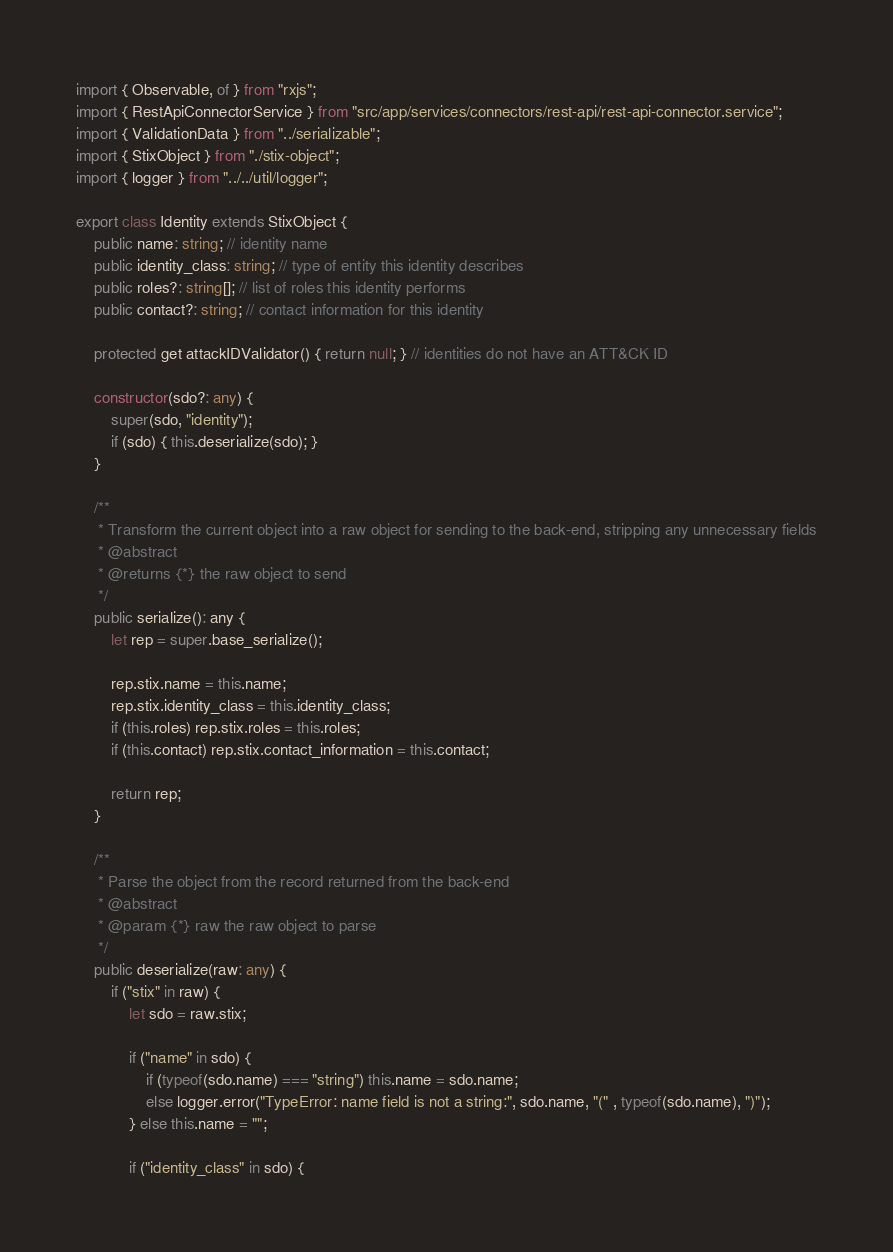<code> <loc_0><loc_0><loc_500><loc_500><_TypeScript_>import { Observable, of } from "rxjs";
import { RestApiConnectorService } from "src/app/services/connectors/rest-api/rest-api-connector.service";
import { ValidationData } from "../serializable";
import { StixObject } from "./stix-object";
import { logger } from "../../util/logger";

export class Identity extends StixObject {
    public name: string; // identity name
    public identity_class: string; // type of entity this identity describes
    public roles?: string[]; // list of roles this identity performs
    public contact?: string; // contact information for this identity

    protected get attackIDValidator() { return null; } // identities do not have an ATT&CK ID

    constructor(sdo?: any) {
        super(sdo, "identity");
        if (sdo) { this.deserialize(sdo); }
    }

    /**
     * Transform the current object into a raw object for sending to the back-end, stripping any unnecessary fields
     * @abstract
     * @returns {*} the raw object to send
     */
    public serialize(): any {
        let rep = super.base_serialize();

        rep.stix.name = this.name;
        rep.stix.identity_class = this.identity_class;
        if (this.roles) rep.stix.roles = this.roles;
        if (this.contact) rep.stix.contact_information = this.contact;

        return rep;
    }
    
    /**
     * Parse the object from the record returned from the back-end
     * @abstract
     * @param {*} raw the raw object to parse
     */
    public deserialize(raw: any) {
        if ("stix" in raw) {
            let sdo = raw.stix;

            if ("name" in sdo) {
                if (typeof(sdo.name) === "string") this.name = sdo.name;
                else logger.error("TypeError: name field is not a string:", sdo.name, "(" , typeof(sdo.name), ")");
            } else this.name = "";

            if ("identity_class" in sdo) {</code> 